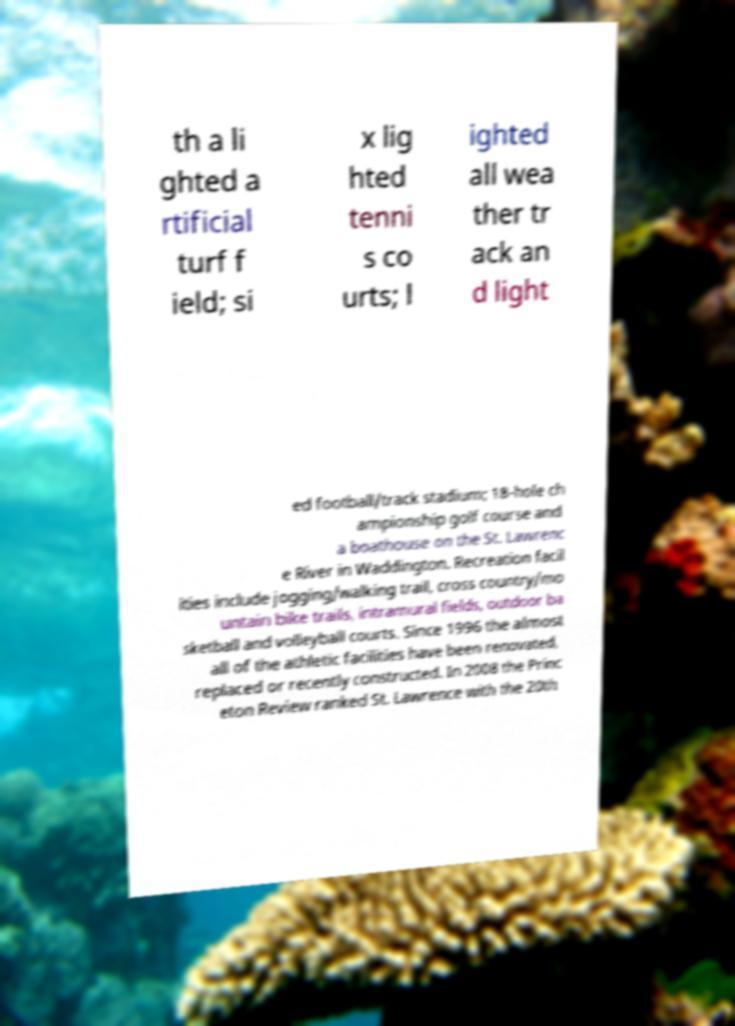Can you accurately transcribe the text from the provided image for me? th a li ghted a rtificial turf f ield; si x lig hted tenni s co urts; l ighted all wea ther tr ack an d light ed football/track stadium; 18-hole ch ampionship golf course and a boathouse on the St. Lawrenc e River in Waddington. Recreation facil ities include jogging/walking trail, cross country/mo untain bike trails, intramural fields, outdoor ba sketball and volleyball courts. Since 1996 the almost all of the athletic facilities have been renovated, replaced or recently constructed. In 2008 the Princ eton Review ranked St. Lawrence with the 20th 